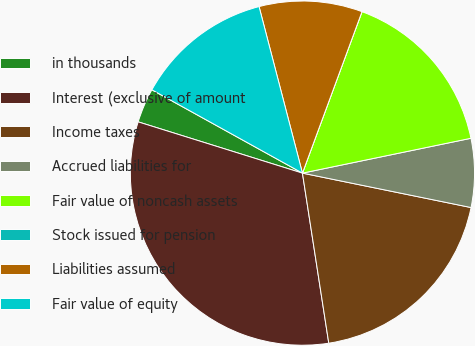Convert chart. <chart><loc_0><loc_0><loc_500><loc_500><pie_chart><fcel>in thousands<fcel>Interest (exclusive of amount<fcel>Income taxes<fcel>Accrued liabilities for<fcel>Fair value of noncash assets<fcel>Stock issued for pension<fcel>Liabilities assumed<fcel>Fair value of equity<nl><fcel>3.23%<fcel>32.26%<fcel>19.35%<fcel>6.45%<fcel>16.13%<fcel>0.0%<fcel>9.68%<fcel>12.9%<nl></chart> 